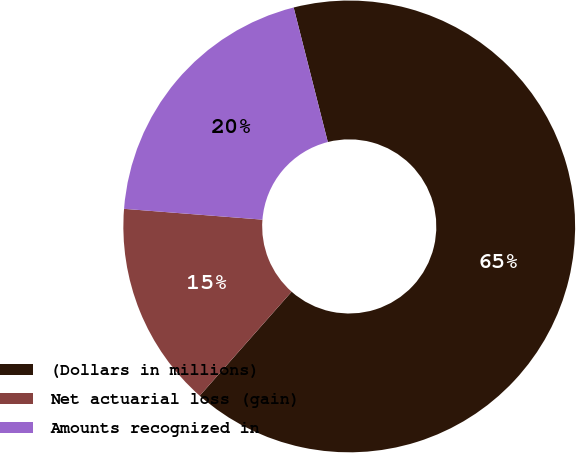Convert chart. <chart><loc_0><loc_0><loc_500><loc_500><pie_chart><fcel>(Dollars in millions)<fcel>Net actuarial loss (gain)<fcel>Amounts recognized in<nl><fcel>65.47%<fcel>14.73%<fcel>19.8%<nl></chart> 